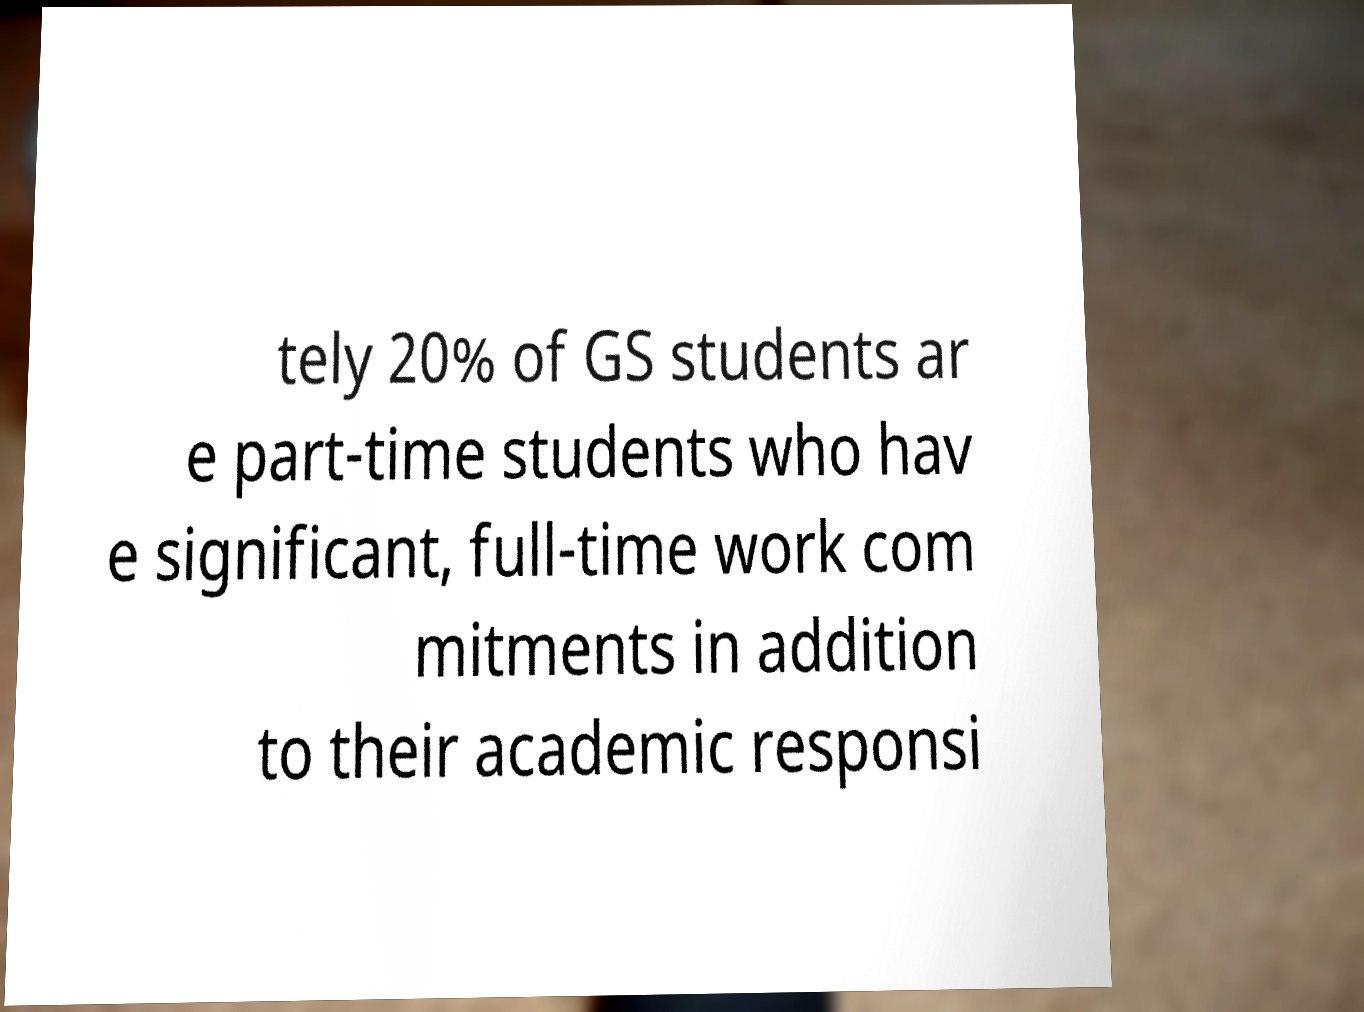Can you accurately transcribe the text from the provided image for me? tely 20% of GS students ar e part-time students who hav e significant, full-time work com mitments in addition to their academic responsi 